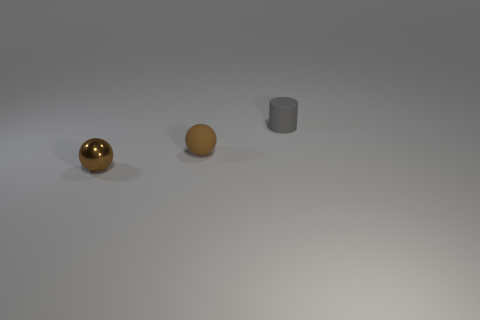Assuming these objects were part of a still life composition, what kind of mood do you think the arrangement conveys? This still life composition imparts a sense of simplicity and balance, with its sparse arrangement and the muted color palette. The uncluttered space and the soft lighting contribute to a calm and contemplative mood. The symmetry and spacing of the objects might symbolize harmony and order. 